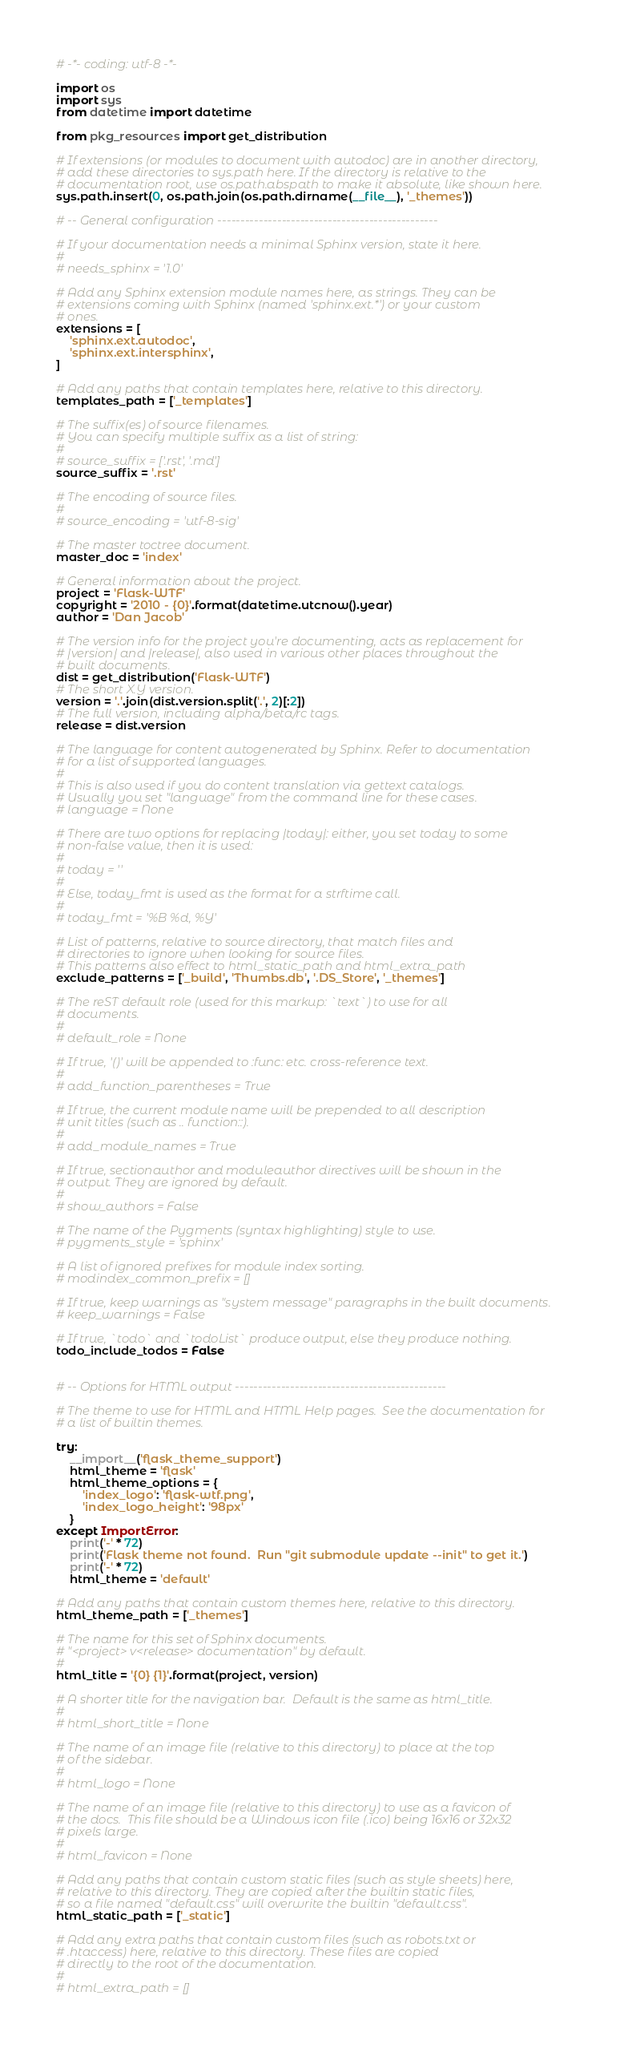Convert code to text. <code><loc_0><loc_0><loc_500><loc_500><_Python_># -*- coding: utf-8 -*-

import os
import sys
from datetime import datetime

from pkg_resources import get_distribution

# If extensions (or modules to document with autodoc) are in another directory,
# add these directories to sys.path here. If the directory is relative to the
# documentation root, use os.path.abspath to make it absolute, like shown here.
sys.path.insert(0, os.path.join(os.path.dirname(__file__), '_themes'))

# -- General configuration ------------------------------------------------

# If your documentation needs a minimal Sphinx version, state it here.
#
# needs_sphinx = '1.0'

# Add any Sphinx extension module names here, as strings. They can be
# extensions coming with Sphinx (named 'sphinx.ext.*') or your custom
# ones.
extensions = [
    'sphinx.ext.autodoc',
    'sphinx.ext.intersphinx',
]

# Add any paths that contain templates here, relative to this directory.
templates_path = ['_templates']

# The suffix(es) of source filenames.
# You can specify multiple suffix as a list of string:
#
# source_suffix = ['.rst', '.md']
source_suffix = '.rst'

# The encoding of source files.
#
# source_encoding = 'utf-8-sig'

# The master toctree document.
master_doc = 'index'

# General information about the project.
project = 'Flask-WTF'
copyright = '2010 - {0}'.format(datetime.utcnow().year)
author = 'Dan Jacob'

# The version info for the project you're documenting, acts as replacement for
# |version| and |release|, also used in various other places throughout the
# built documents.
dist = get_distribution('Flask-WTF')
# The short X.Y version.
version = '.'.join(dist.version.split('.', 2)[:2])
# The full version, including alpha/beta/rc tags.
release = dist.version

# The language for content autogenerated by Sphinx. Refer to documentation
# for a list of supported languages.
#
# This is also used if you do content translation via gettext catalogs.
# Usually you set "language" from the command line for these cases.
# language = None

# There are two options for replacing |today|: either, you set today to some
# non-false value, then it is used:
#
# today = ''
#
# Else, today_fmt is used as the format for a strftime call.
#
# today_fmt = '%B %d, %Y'

# List of patterns, relative to source directory, that match files and
# directories to ignore when looking for source files.
# This patterns also effect to html_static_path and html_extra_path
exclude_patterns = ['_build', 'Thumbs.db', '.DS_Store', '_themes']

# The reST default role (used for this markup: `text`) to use for all
# documents.
#
# default_role = None

# If true, '()' will be appended to :func: etc. cross-reference text.
#
# add_function_parentheses = True

# If true, the current module name will be prepended to all description
# unit titles (such as .. function::).
#
# add_module_names = True

# If true, sectionauthor and moduleauthor directives will be shown in the
# output. They are ignored by default.
#
# show_authors = False

# The name of the Pygments (syntax highlighting) style to use.
# pygments_style = 'sphinx'

# A list of ignored prefixes for module index sorting.
# modindex_common_prefix = []

# If true, keep warnings as "system message" paragraphs in the built documents.
# keep_warnings = False

# If true, `todo` and `todoList` produce output, else they produce nothing.
todo_include_todos = False


# -- Options for HTML output ----------------------------------------------

# The theme to use for HTML and HTML Help pages.  See the documentation for
# a list of builtin themes.

try:
    __import__('flask_theme_support')
    html_theme = 'flask'
    html_theme_options = {
        'index_logo': 'flask-wtf.png',
        'index_logo_height': '98px'
    }
except ImportError:
    print('-' * 72)
    print('Flask theme not found.  Run "git submodule update --init" to get it.')
    print('-' * 72)
    html_theme = 'default'

# Add any paths that contain custom themes here, relative to this directory.
html_theme_path = ['_themes']

# The name for this set of Sphinx documents.
# "<project> v<release> documentation" by default.
#
html_title = '{0} {1}'.format(project, version)

# A shorter title for the navigation bar.  Default is the same as html_title.
#
# html_short_title = None

# The name of an image file (relative to this directory) to place at the top
# of the sidebar.
#
# html_logo = None

# The name of an image file (relative to this directory) to use as a favicon of
# the docs.  This file should be a Windows icon file (.ico) being 16x16 or 32x32
# pixels large.
#
# html_favicon = None

# Add any paths that contain custom static files (such as style sheets) here,
# relative to this directory. They are copied after the builtin static files,
# so a file named "default.css" will overwrite the builtin "default.css".
html_static_path = ['_static']

# Add any extra paths that contain custom files (such as robots.txt or
# .htaccess) here, relative to this directory. These files are copied
# directly to the root of the documentation.
#
# html_extra_path = []
</code> 